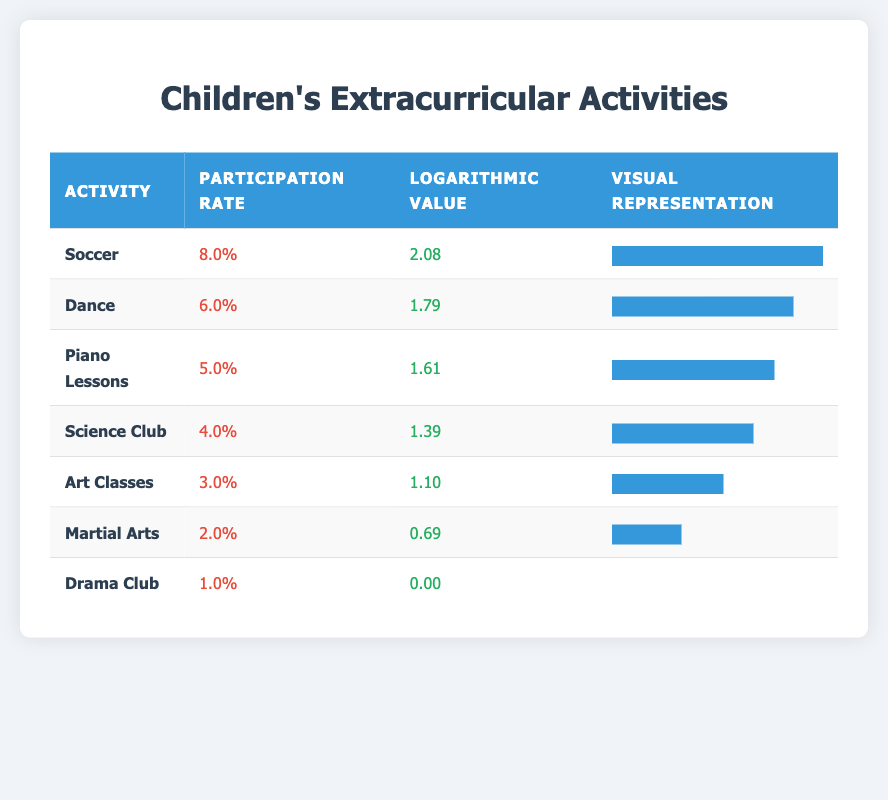What is the participation rate of the Science Club? The table lists the participation rates of different activities. Looking at the row for Science Club, the participation rate is shown as 4.0%.
Answer: 4.0% Which activity has the highest participation rate? The highest participation rate can be found by comparing all the activities. The row for Soccer shows a participation rate of 8.0%, which is the highest among all listed activities.
Answer: Soccer What is the logarithmic value of Dance? The logarithmic value for each activity can be found in the corresponding column. For Dance, the value listed is 1.79.
Answer: 1.79 What is the average participation rate of the activities? To find the average, first sum the participation rates: 8.0 + 6.0 + 5.0 + 4.0 + 3.0 + 2.0 + 1.0 = 29.0. Then divide this sum by the number of activities (7): 29.0 / 7 = 4.14.
Answer: 4.14 Is the participation rate of Martial Arts higher than that of Art Classes? By checking the participation rates in the table, Martial Arts has a rate of 2.0%, and Art Classes have a rate of 3.0%. Since 2.0% is not higher than 3.0%, the answer is no.
Answer: No What are the two activities with the lowest participation rates? The lowest participation rates can be found by checking the last rows of the table. The lowest is Drama Club at 1.0% and the second lowest is Martial Arts at 2.0%.
Answer: Drama Club and Martial Arts If a child participates in both Soccer and Dance, what would be the combined participation rates? The participation rates for Soccer (8.0%) and Dance (6.0%) need to be summed: 8.0 + 6.0 = 14.0.
Answer: 14.0 Is the logarithmic value for Art Classes greater than that for Science Club? The logarithmic value for Art Classes is 1.10, and for Science Club, it's 1.39. Since 1.10 is less than 1.39, the answer is no.
Answer: No What is the difference in participation rates between the activity with the highest rate and the one with the lowest rate? The highest participation rate is for Soccer at 8.0%, and the lowest is for Drama Club at 1.0%. Calculate the difference: 8.0 - 1.0 = 7.0.
Answer: 7.0 